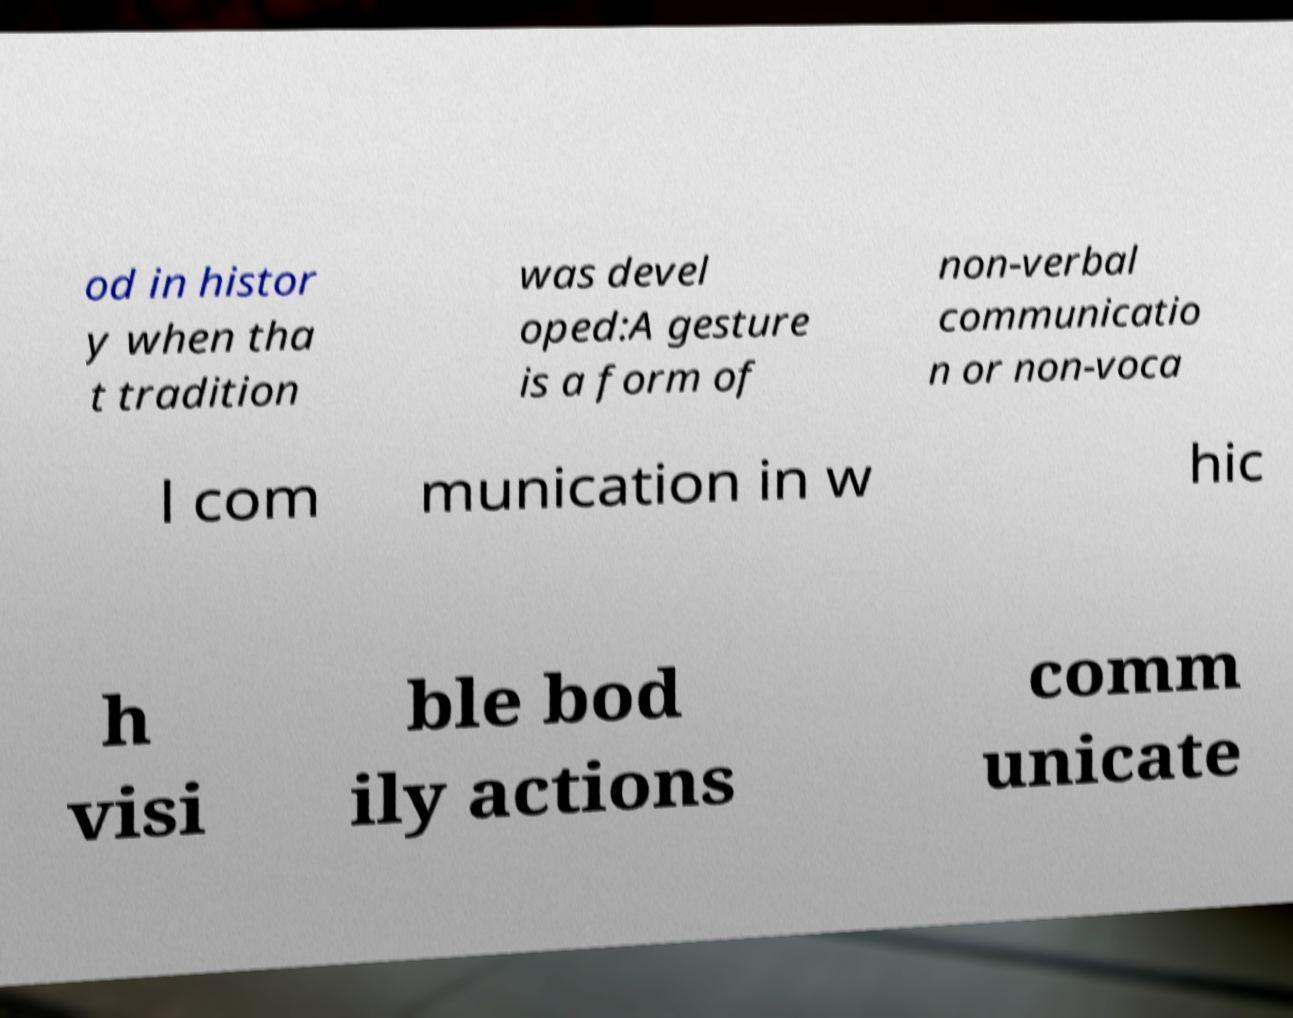Can you read and provide the text displayed in the image?This photo seems to have some interesting text. Can you extract and type it out for me? od in histor y when tha t tradition was devel oped:A gesture is a form of non-verbal communicatio n or non-voca l com munication in w hic h visi ble bod ily actions comm unicate 